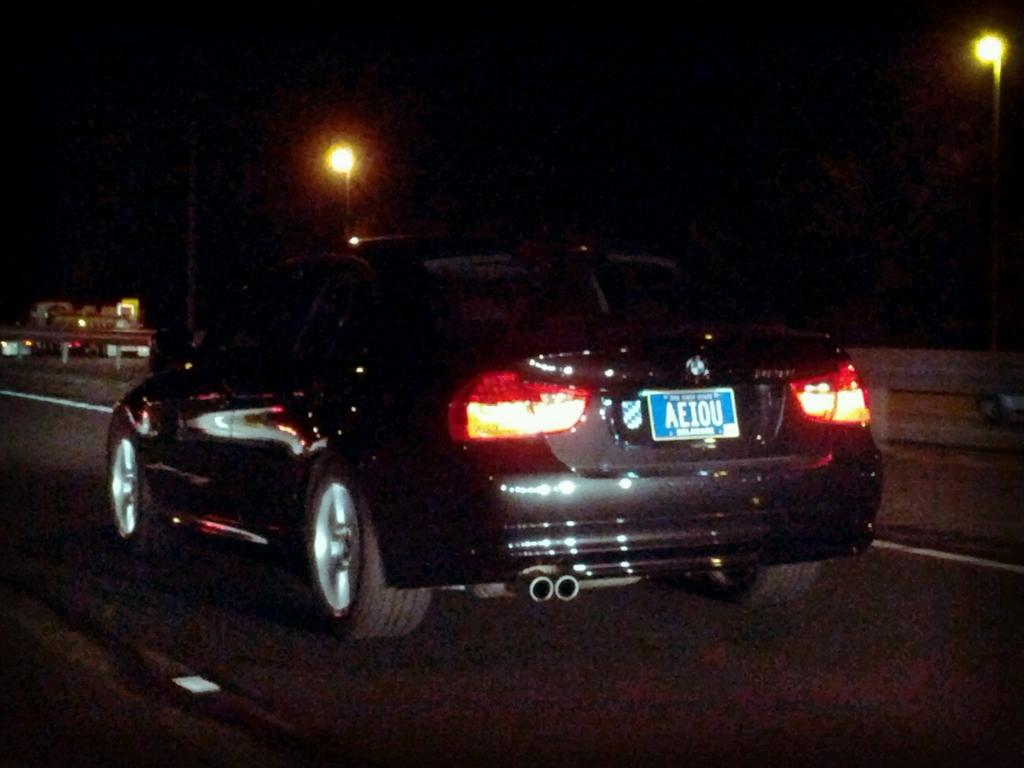What is at the bottom of the image? There is a road at the bottom of the image. What is in the middle of the road? There is a black car in the middle of the road. What features does the car have? The car has lights and a name plate. What is the color of the background in the image? The background of the image is black. What else can be seen in the background? There are lights in the background. Where is the lunchroom located in the image? There is no lunchroom present in the image. What action is the car performing in the image? The car is stationary in the middle of the road, so it is not performing any action. 